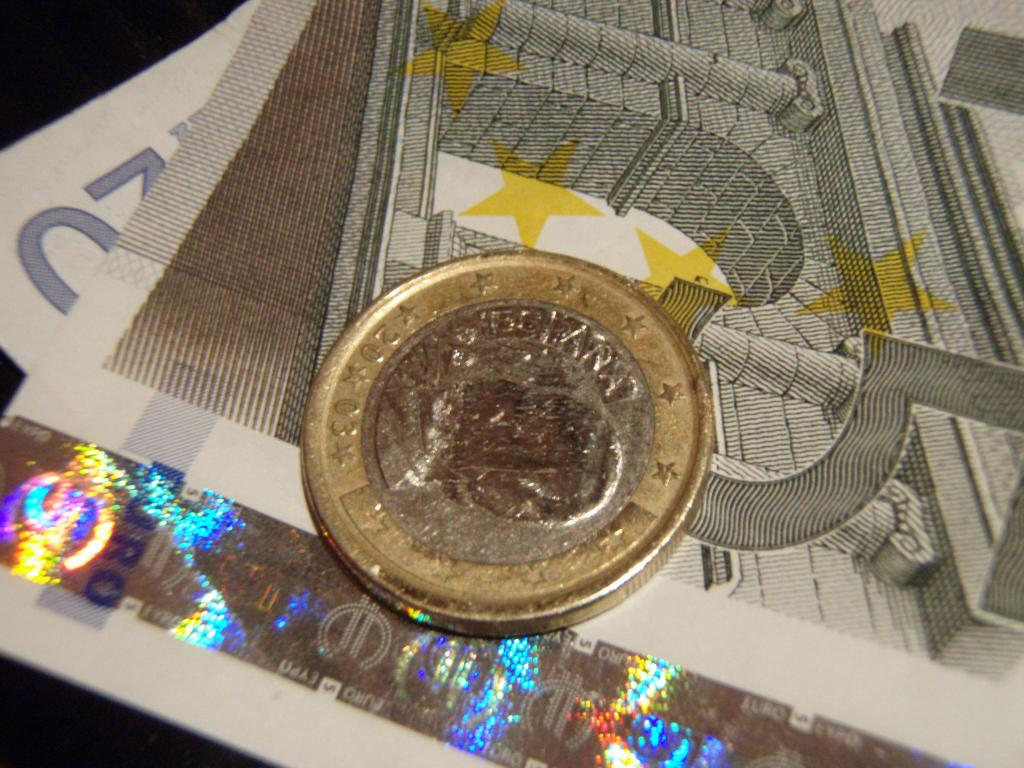What type of money is visible in the image? There are currency notes in the image. What other type of money can be seen in the image? There is a coin in the image. What colors are present on the coin? The coin is gold and silver in color. What design element is present on the coin? The coin has a symbol on it. What type of sofa can be seen in the image? There is no sofa present in the image. What shape is the top of the coin in the image? The shape of the coin in the image is not mentioned, but it is likely round since it is a coin. 